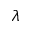Convert formula to latex. <formula><loc_0><loc_0><loc_500><loc_500>\lambda</formula> 